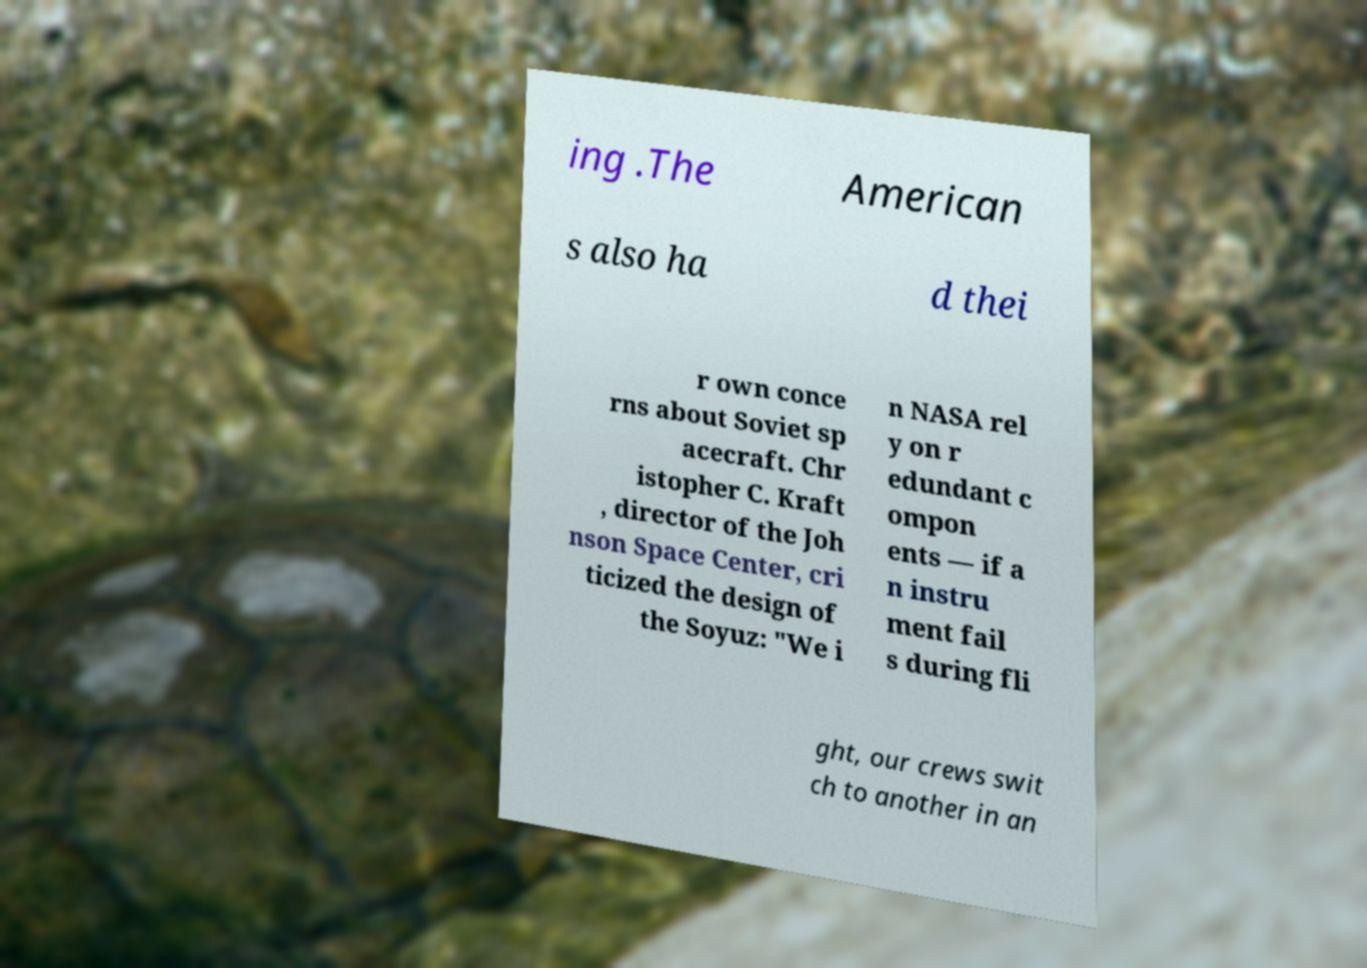What messages or text are displayed in this image? I need them in a readable, typed format. ing .The American s also ha d thei r own conce rns about Soviet sp acecraft. Chr istopher C. Kraft , director of the Joh nson Space Center, cri ticized the design of the Soyuz: "We i n NASA rel y on r edundant c ompon ents — if a n instru ment fail s during fli ght, our crews swit ch to another in an 